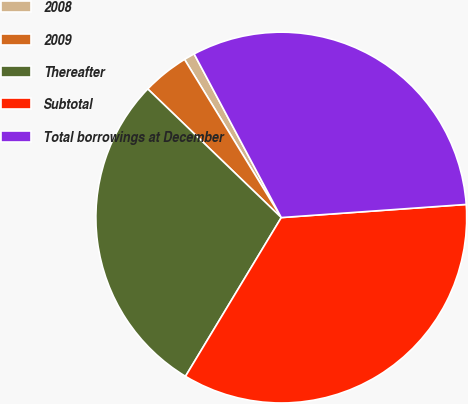<chart> <loc_0><loc_0><loc_500><loc_500><pie_chart><fcel>2008<fcel>2009<fcel>Thereafter<fcel>Subtotal<fcel>Total borrowings at December<nl><fcel>0.95%<fcel>4.06%<fcel>28.56%<fcel>34.77%<fcel>31.66%<nl></chart> 